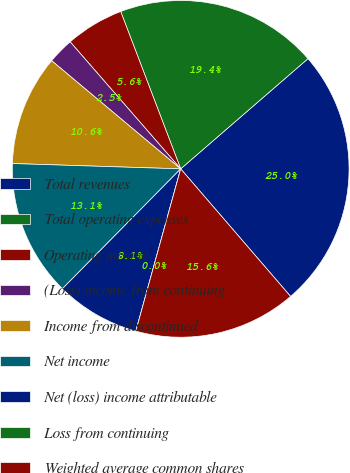Convert chart. <chart><loc_0><loc_0><loc_500><loc_500><pie_chart><fcel>Total revenues<fcel>Total operating expenses<fcel>Operating income<fcel>(Loss) income from continuing<fcel>Income from discontinued<fcel>Net income<fcel>Net (loss) income attributable<fcel>Loss from continuing<fcel>Weighted average common shares<nl><fcel>25.04%<fcel>19.44%<fcel>5.6%<fcel>2.5%<fcel>10.6%<fcel>13.11%<fcel>8.1%<fcel>0.0%<fcel>15.61%<nl></chart> 